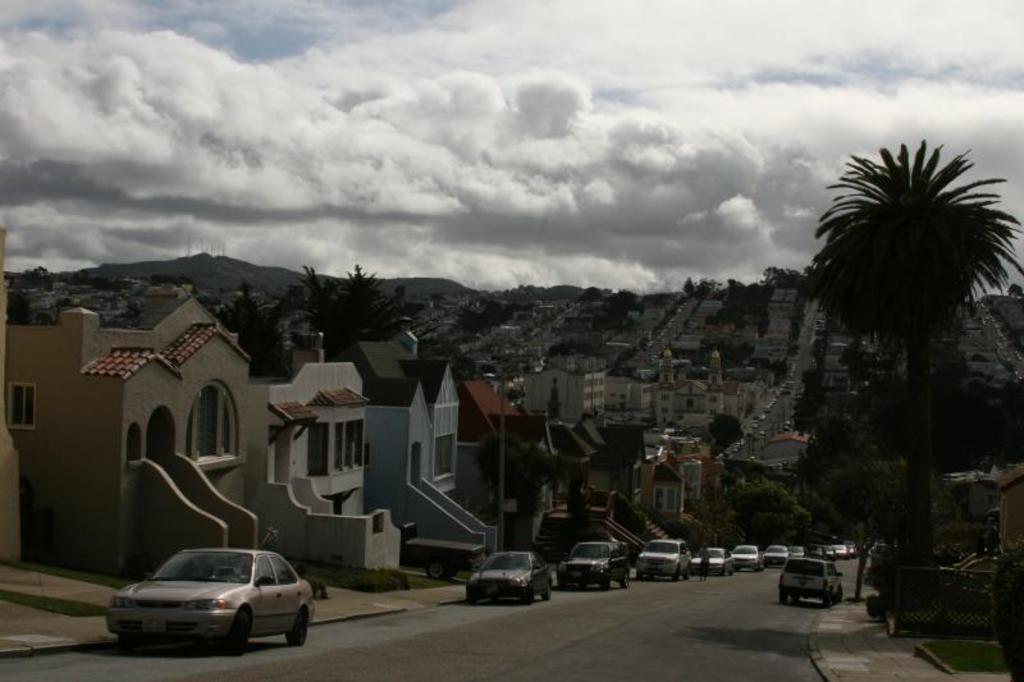In one or two sentences, can you explain what this image depicts? At the bottom of the image there is a road. On the roads there are many cars. On the right side of the image there is a footpath with fencing and some other items. In the image there are many buildings with walls, roofs and windows. And also there are many trees. In the background there is a hill. At the top of the image there is sky with clouds. 